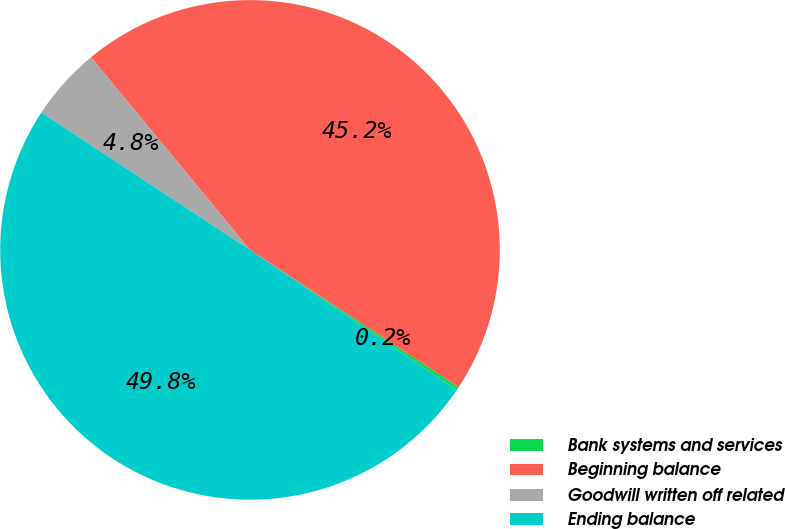<chart> <loc_0><loc_0><loc_500><loc_500><pie_chart><fcel>Bank systems and services<fcel>Beginning balance<fcel>Goodwill written off related<fcel>Ending balance<nl><fcel>0.22%<fcel>45.25%<fcel>4.75%<fcel>49.78%<nl></chart> 